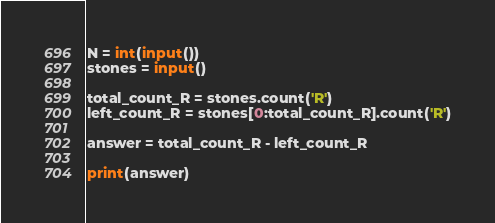Convert code to text. <code><loc_0><loc_0><loc_500><loc_500><_Python_>N = int(input())
stones = input()

total_count_R = stones.count('R')
left_count_R = stones[0:total_count_R].count('R')

answer = total_count_R - left_count_R

print(answer)</code> 